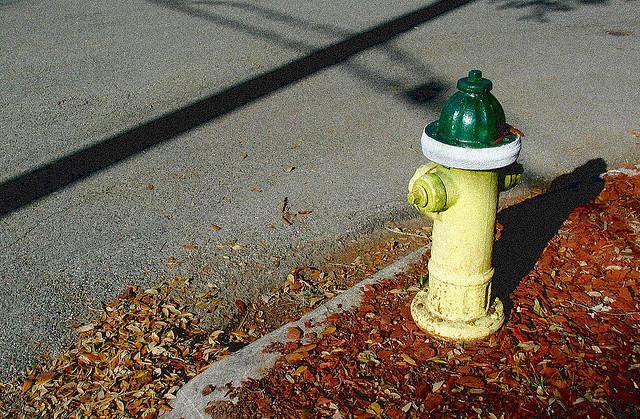Is the sun to the right or the left of the photographer?
Short answer required. Left. What color is the top of the hydrant?
Answer briefly. Green. How many hoses are attached to the hydrant?
Quick response, please. 0. Should a car park here?
Be succinct. No. What surrounds the hydrant?
Short answer required. Leaves. Has the hydrant been installed?
Be succinct. Yes. Is there a lighter in the picture?
Concise answer only. No. What comes out of this device?
Quick response, please. Water. What color is the grass?
Concise answer only. Brown. Is this item used for cooking?
Answer briefly. No. Is the ground partly brown?
Short answer required. Yes. 